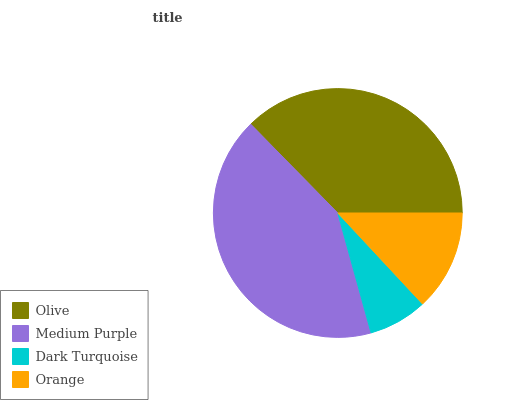Is Dark Turquoise the minimum?
Answer yes or no. Yes. Is Medium Purple the maximum?
Answer yes or no. Yes. Is Medium Purple the minimum?
Answer yes or no. No. Is Dark Turquoise the maximum?
Answer yes or no. No. Is Medium Purple greater than Dark Turquoise?
Answer yes or no. Yes. Is Dark Turquoise less than Medium Purple?
Answer yes or no. Yes. Is Dark Turquoise greater than Medium Purple?
Answer yes or no. No. Is Medium Purple less than Dark Turquoise?
Answer yes or no. No. Is Olive the high median?
Answer yes or no. Yes. Is Orange the low median?
Answer yes or no. Yes. Is Dark Turquoise the high median?
Answer yes or no. No. Is Medium Purple the low median?
Answer yes or no. No. 